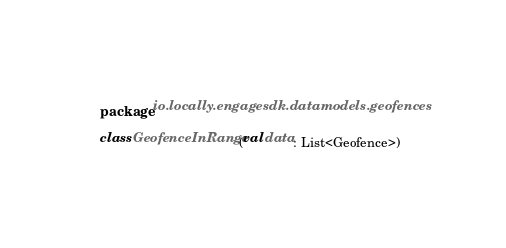Convert code to text. <code><loc_0><loc_0><loc_500><loc_500><_Kotlin_>package io.locally.engagesdk.datamodels.geofences

class GeofenceInRange(val data: List<Geofence>)</code> 